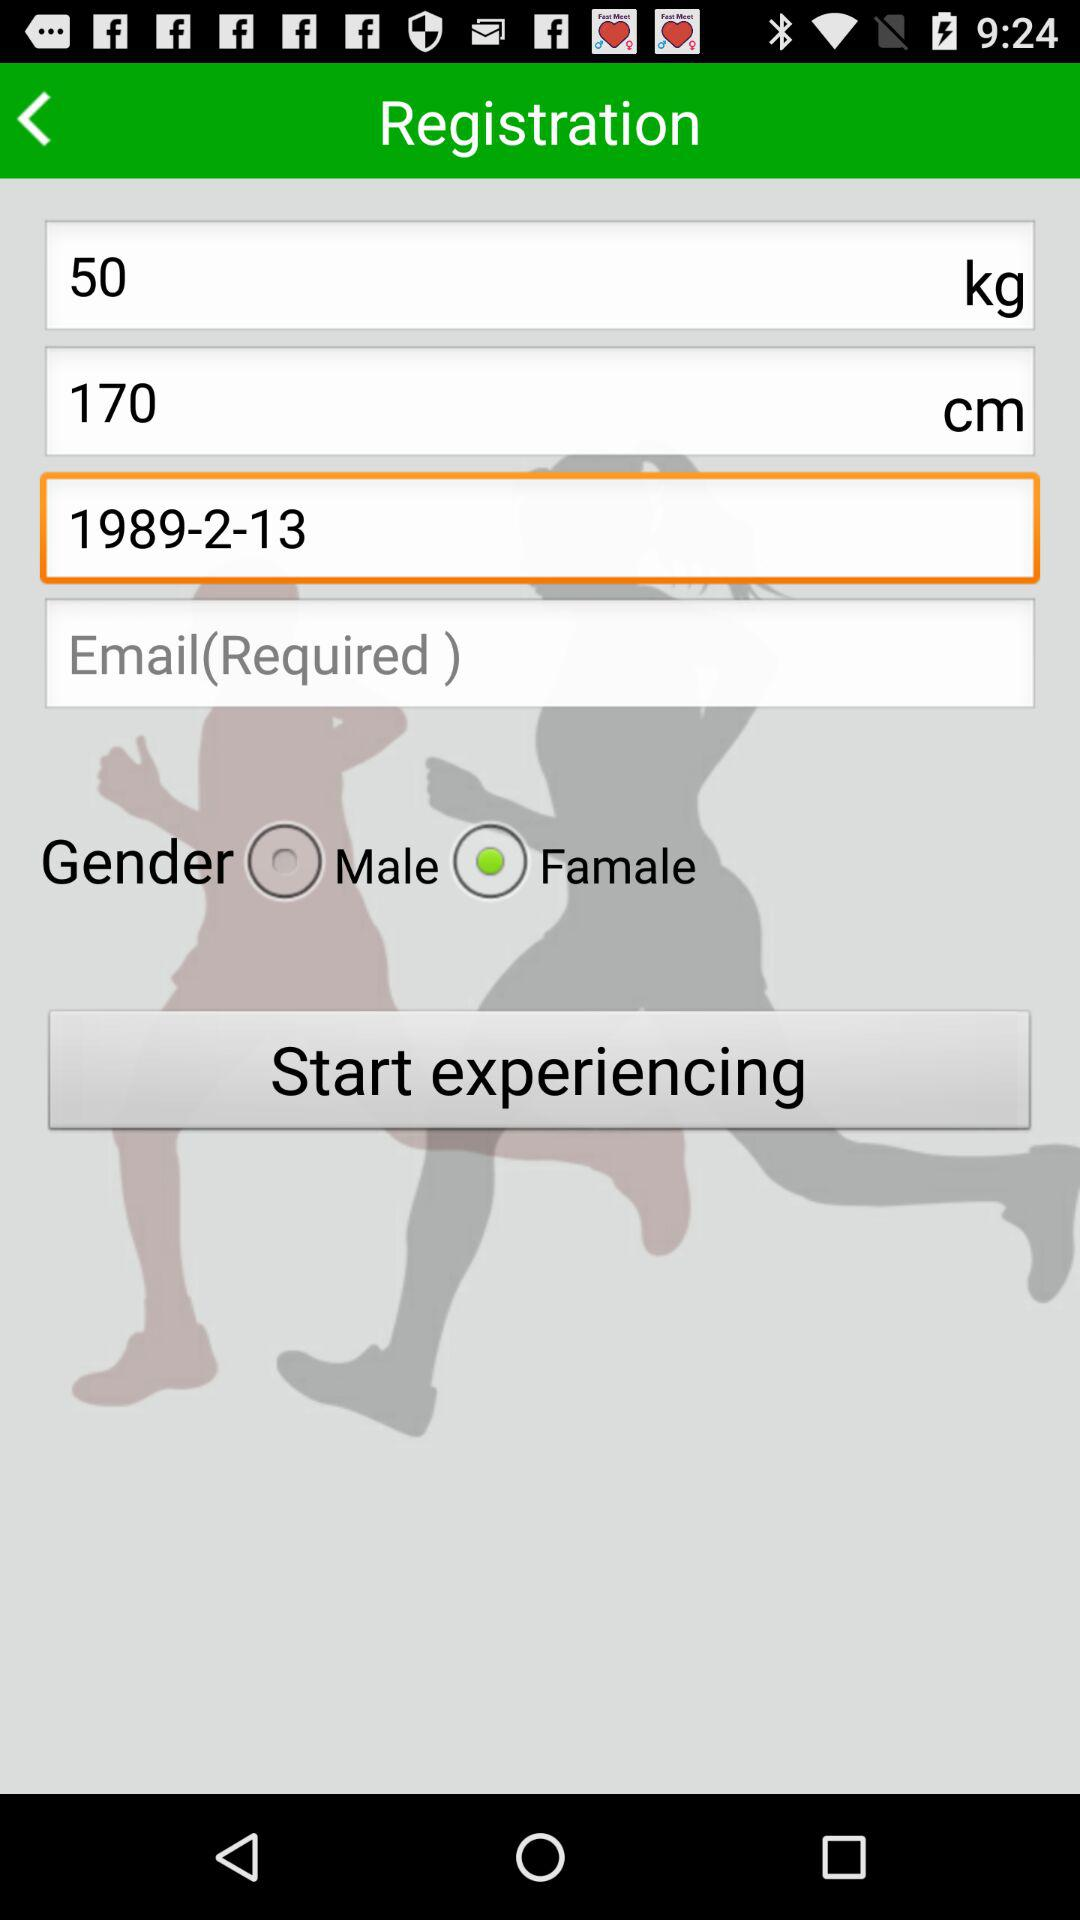What is the date of birth? The date of birth is February 13, 1989. 